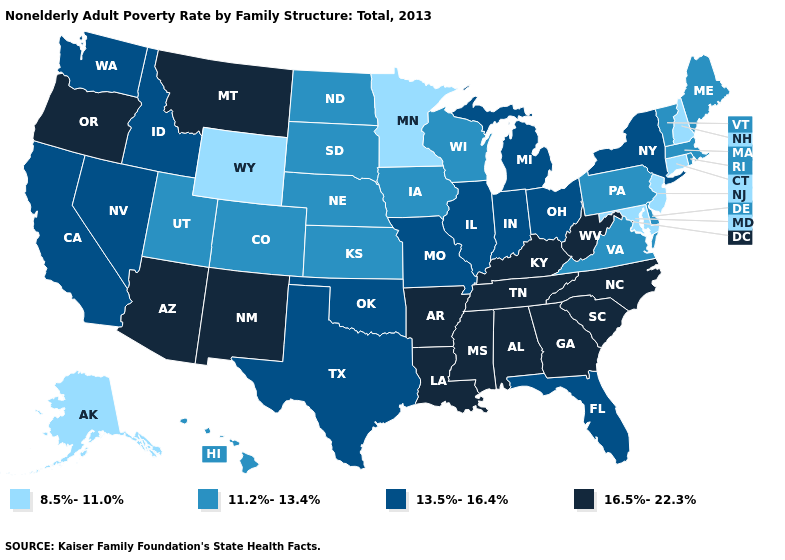What is the value of Pennsylvania?
Write a very short answer. 11.2%-13.4%. What is the value of Tennessee?
Short answer required. 16.5%-22.3%. Does Florida have a lower value than Indiana?
Answer briefly. No. Is the legend a continuous bar?
Answer briefly. No. Is the legend a continuous bar?
Give a very brief answer. No. What is the highest value in states that border Louisiana?
Write a very short answer. 16.5%-22.3%. What is the value of South Dakota?
Answer briefly. 11.2%-13.4%. Which states hav the highest value in the MidWest?
Keep it brief. Illinois, Indiana, Michigan, Missouri, Ohio. What is the highest value in the USA?
Keep it brief. 16.5%-22.3%. Which states have the highest value in the USA?
Short answer required. Alabama, Arizona, Arkansas, Georgia, Kentucky, Louisiana, Mississippi, Montana, New Mexico, North Carolina, Oregon, South Carolina, Tennessee, West Virginia. Does New Mexico have a higher value than Georgia?
Answer briefly. No. What is the lowest value in states that border Virginia?
Write a very short answer. 8.5%-11.0%. Does the map have missing data?
Concise answer only. No. Name the states that have a value in the range 11.2%-13.4%?
Short answer required. Colorado, Delaware, Hawaii, Iowa, Kansas, Maine, Massachusetts, Nebraska, North Dakota, Pennsylvania, Rhode Island, South Dakota, Utah, Vermont, Virginia, Wisconsin. Name the states that have a value in the range 11.2%-13.4%?
Be succinct. Colorado, Delaware, Hawaii, Iowa, Kansas, Maine, Massachusetts, Nebraska, North Dakota, Pennsylvania, Rhode Island, South Dakota, Utah, Vermont, Virginia, Wisconsin. 